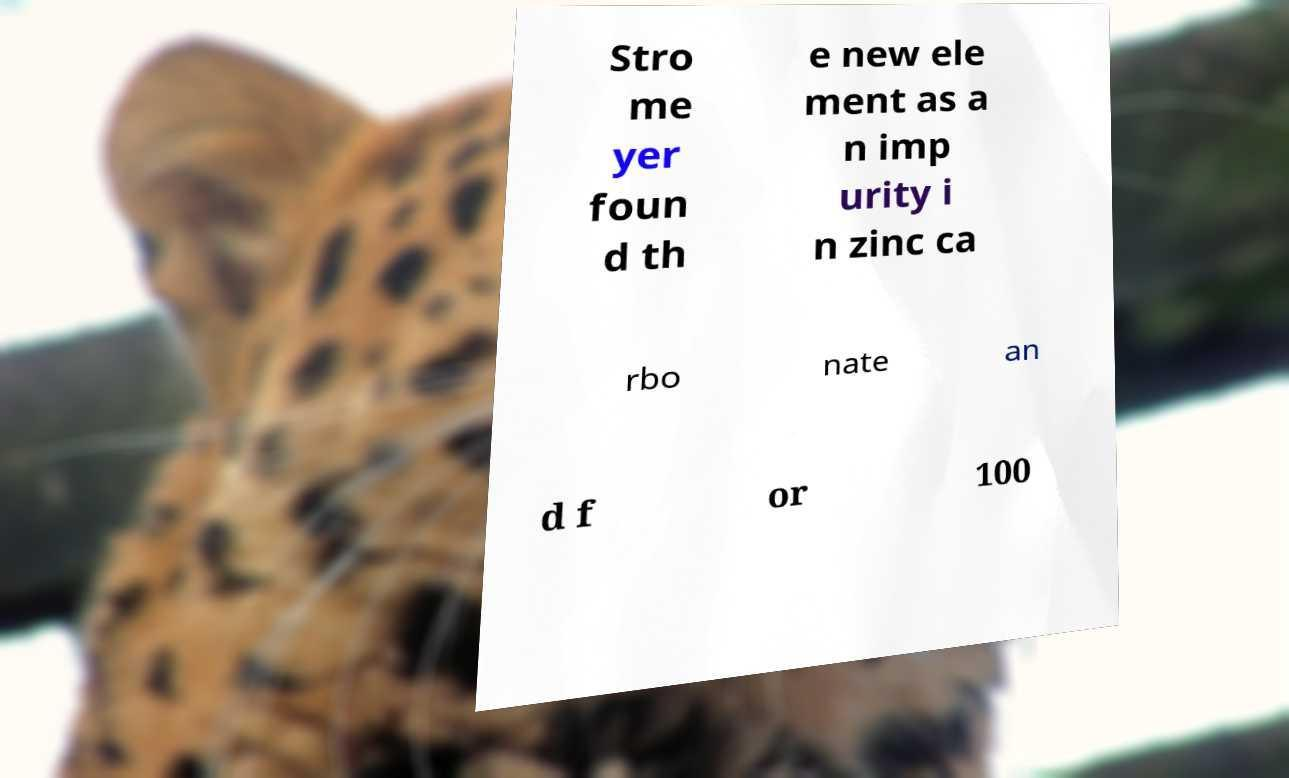For documentation purposes, I need the text within this image transcribed. Could you provide that? Stro me yer foun d th e new ele ment as a n imp urity i n zinc ca rbo nate an d f or 100 